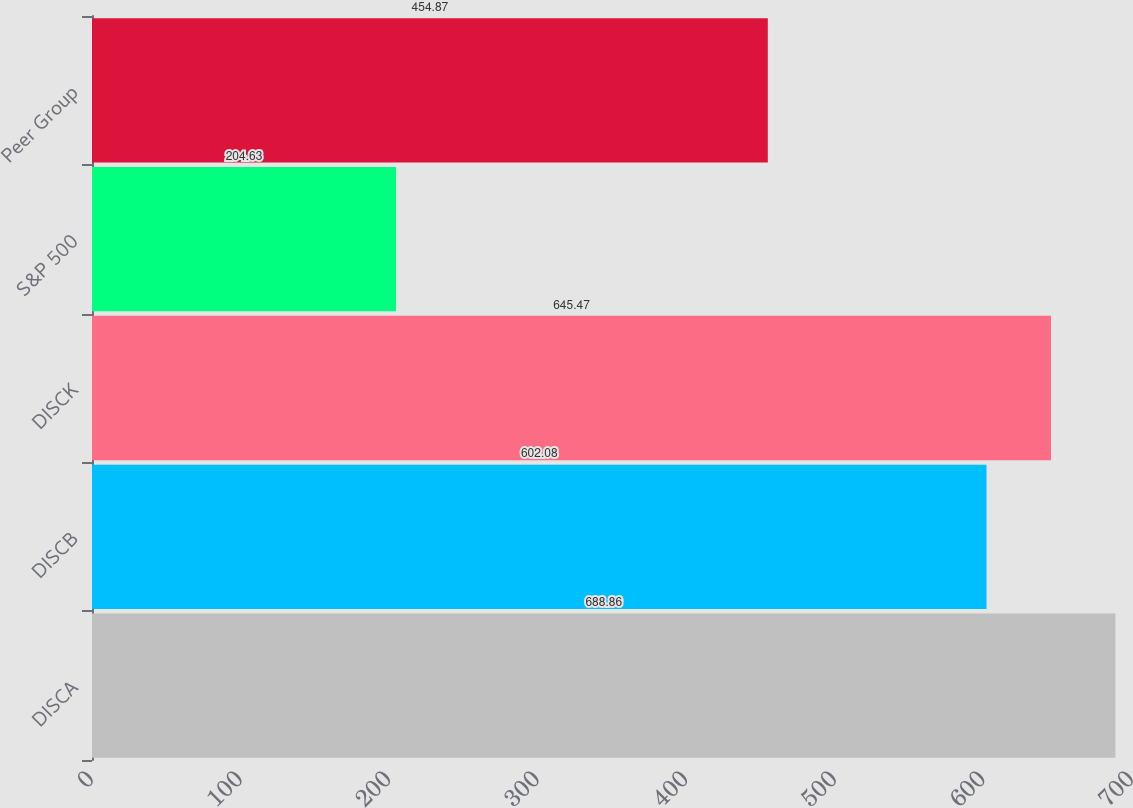Convert chart to OTSL. <chart><loc_0><loc_0><loc_500><loc_500><bar_chart><fcel>DISCA<fcel>DISCB<fcel>DISCK<fcel>S&P 500<fcel>Peer Group<nl><fcel>688.86<fcel>602.08<fcel>645.47<fcel>204.63<fcel>454.87<nl></chart> 